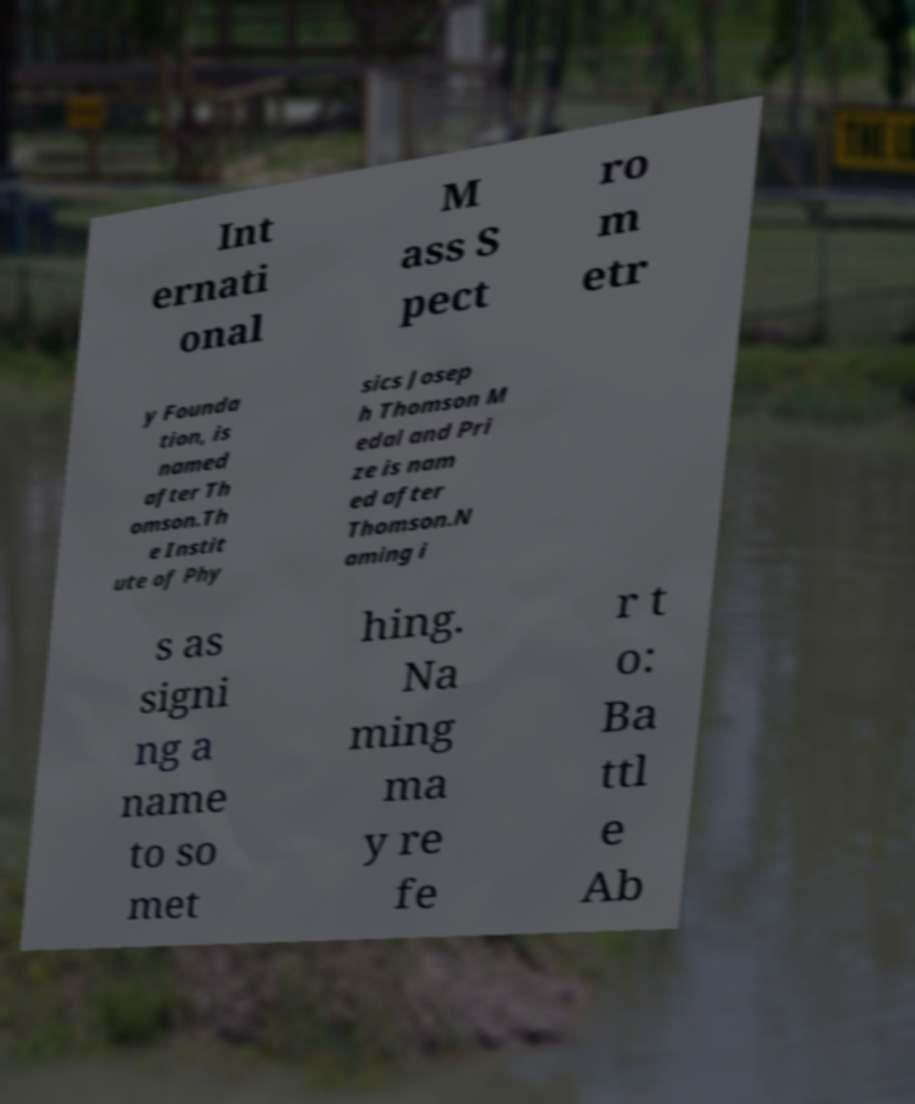For documentation purposes, I need the text within this image transcribed. Could you provide that? Int ernati onal M ass S pect ro m etr y Founda tion, is named after Th omson.Th e Instit ute of Phy sics Josep h Thomson M edal and Pri ze is nam ed after Thomson.N aming i s as signi ng a name to so met hing. Na ming ma y re fe r t o: Ba ttl e Ab 